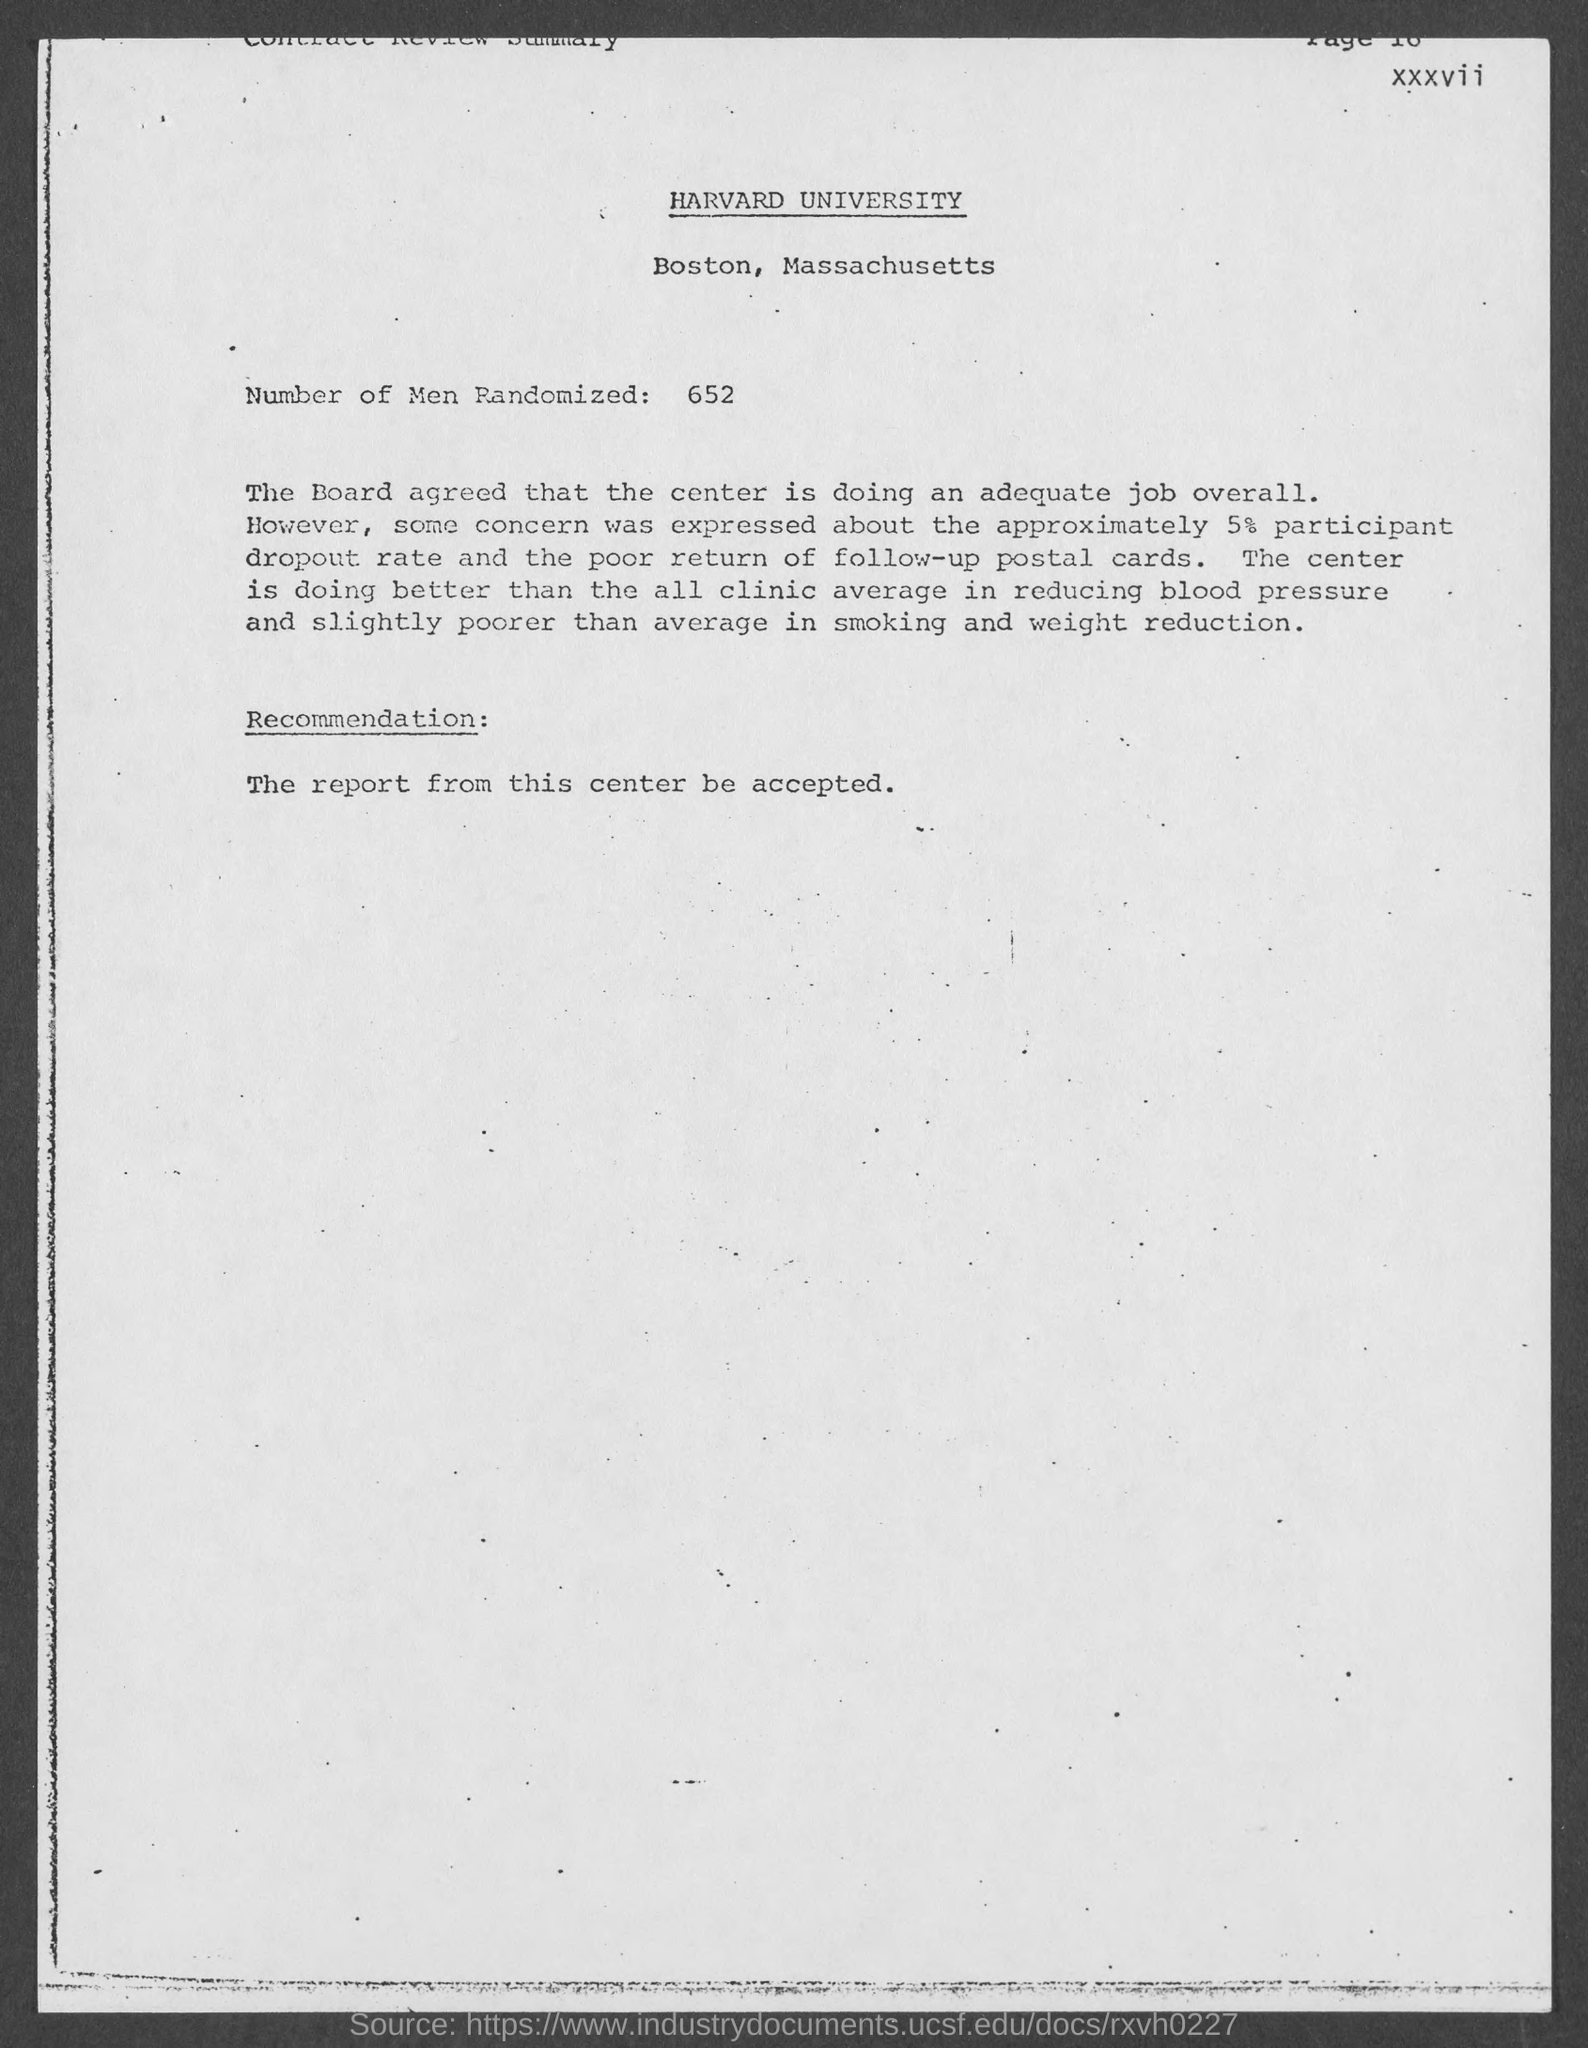Outline some significant characteristics in this image. Harvard University is mentioned in this document. Harvard University is located in Boston. The dropout rate and the poor return of follow-up postal cards are both 5%. The "Number of Men Randomized" is 652. 